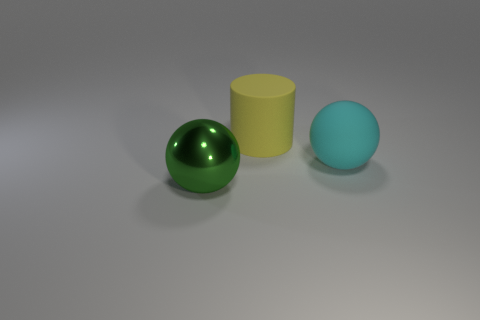Add 1 green balls. How many objects exist? 4 Subtract all cylinders. How many objects are left? 2 Subtract all green spheres. How many spheres are left? 1 Subtract all purple cylinders. Subtract all yellow cubes. How many cylinders are left? 1 Subtract all gray cubes. How many green balls are left? 1 Subtract all yellow things. Subtract all large cyan objects. How many objects are left? 1 Add 1 big green shiny balls. How many big green shiny balls are left? 2 Add 1 objects. How many objects exist? 4 Subtract 0 purple blocks. How many objects are left? 3 